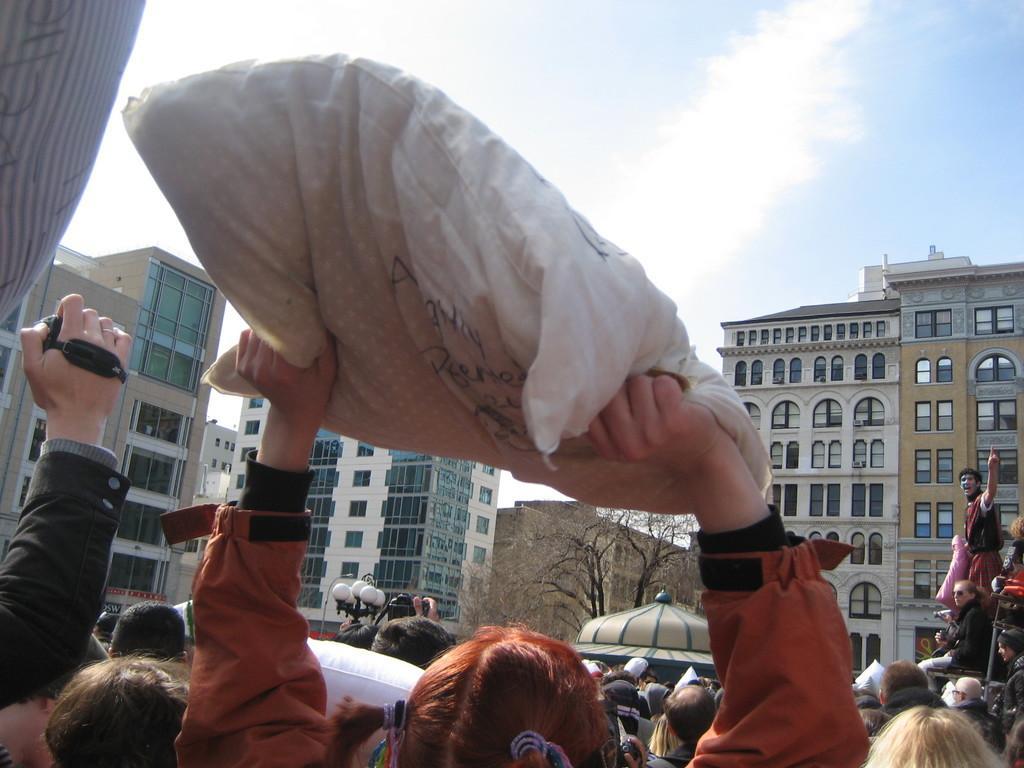Describe this image in one or two sentences. At the bottom of the image, we can see a group of people. Few people are holding some objects. Here a person is holding a cushion. Background we can see street lights, buildings, trees, walls, glass windows and sky. 